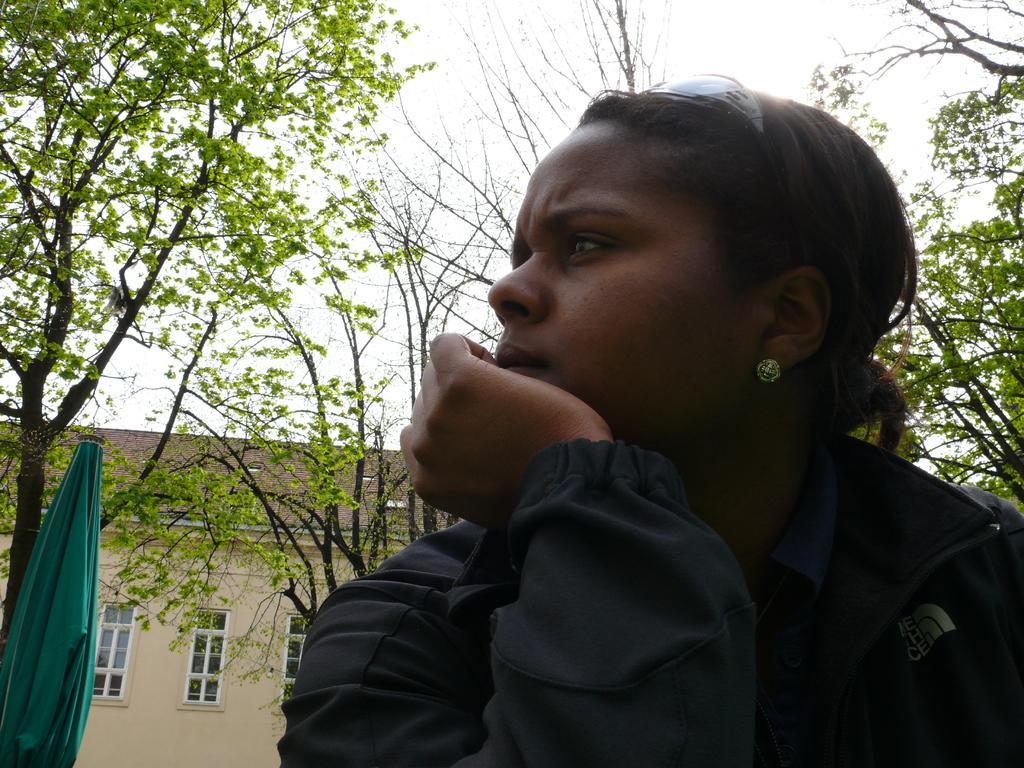Could you give a brief overview of what you see in this image? In this picture we can see a woman and in the background we can see a cloth, house, trees, sky. 